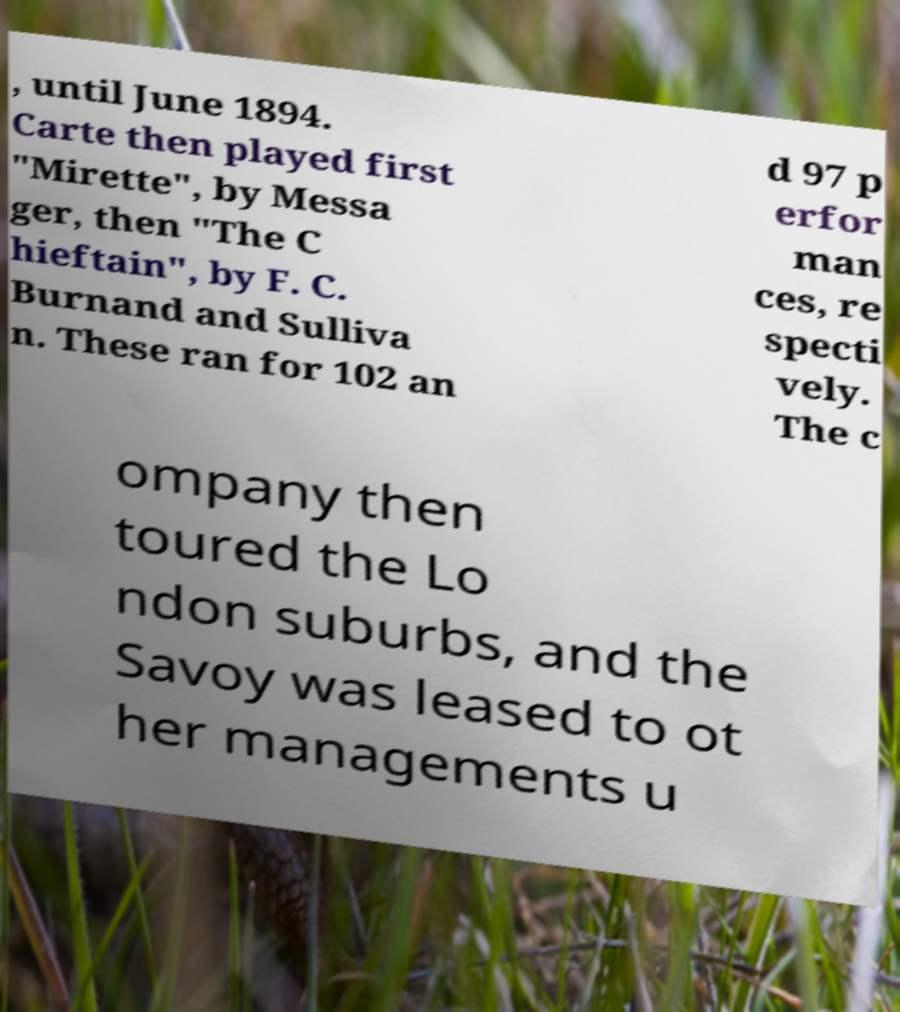Please read and relay the text visible in this image. What does it say? , until June 1894. Carte then played first "Mirette", by Messa ger, then "The C hieftain", by F. C. Burnand and Sulliva n. These ran for 102 an d 97 p erfor man ces, re specti vely. The c ompany then toured the Lo ndon suburbs, and the Savoy was leased to ot her managements u 